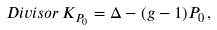Convert formula to latex. <formula><loc_0><loc_0><loc_500><loc_500>D i v i s o r \, K _ { P _ { 0 } } = \Delta - ( g - 1 ) P _ { 0 } \, ,</formula> 